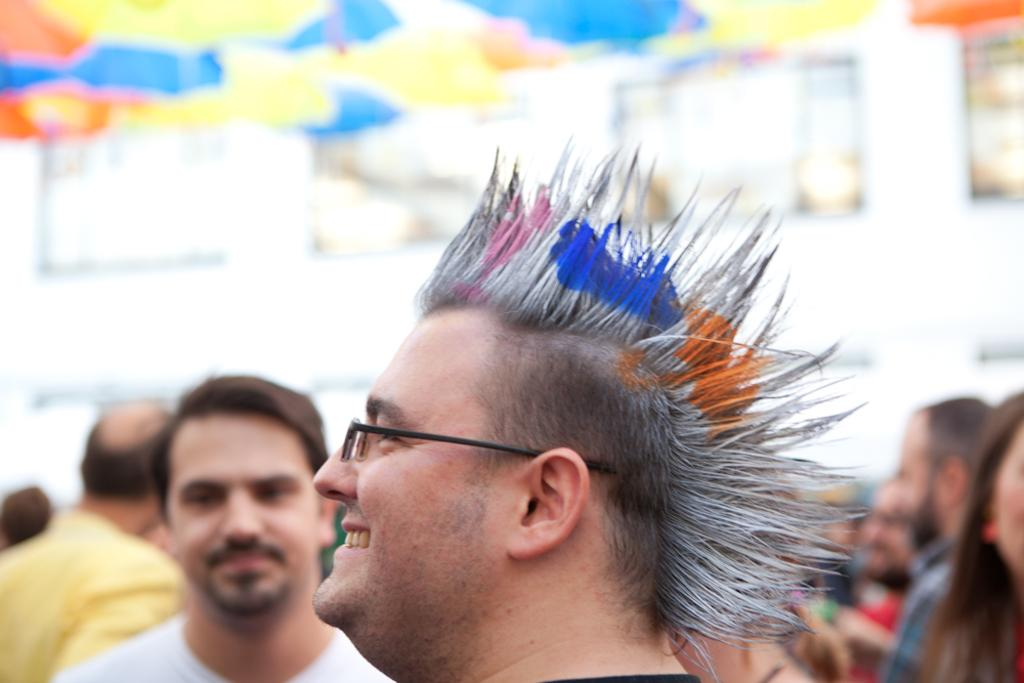How many people are in the image? There are persons in the image, but the exact number cannot be determined due to the blurriness. Can you describe any objects visible in the background of the image? Despite the blurriness, there are objects visible in the background of the image, but their specific details cannot be discerned. What type of stem is being used by the writer in the image? There is no writer or stem present in the image. How does the swimmer in the image perform a backstroke? There is no swimmer or backstroke in the image. 